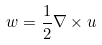<formula> <loc_0><loc_0><loc_500><loc_500>w = \frac { 1 } { 2 } \nabla \times u</formula> 